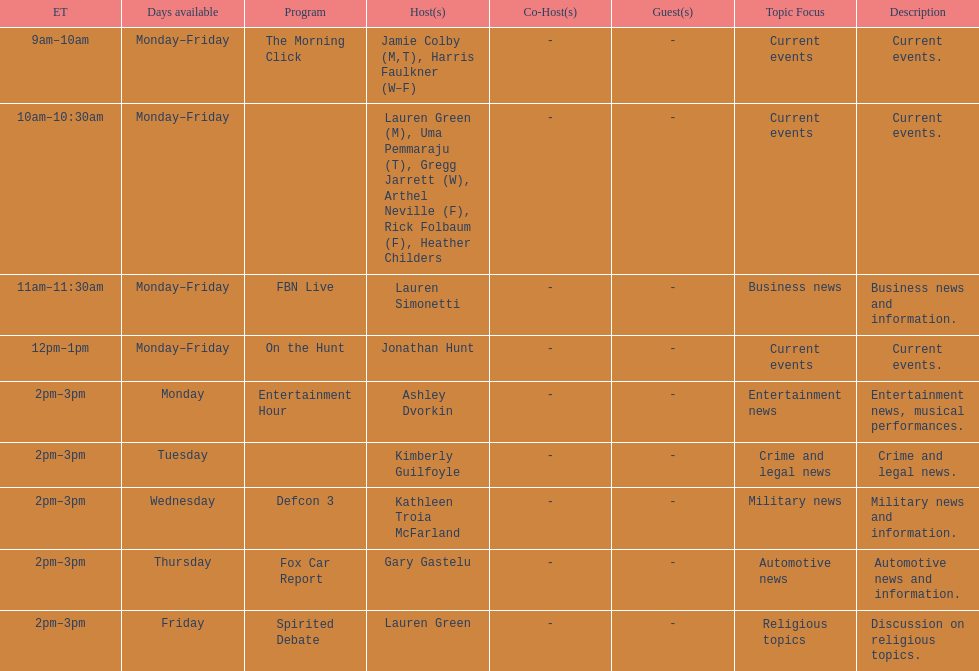How many days during the week does the show fbn live air? 5. 